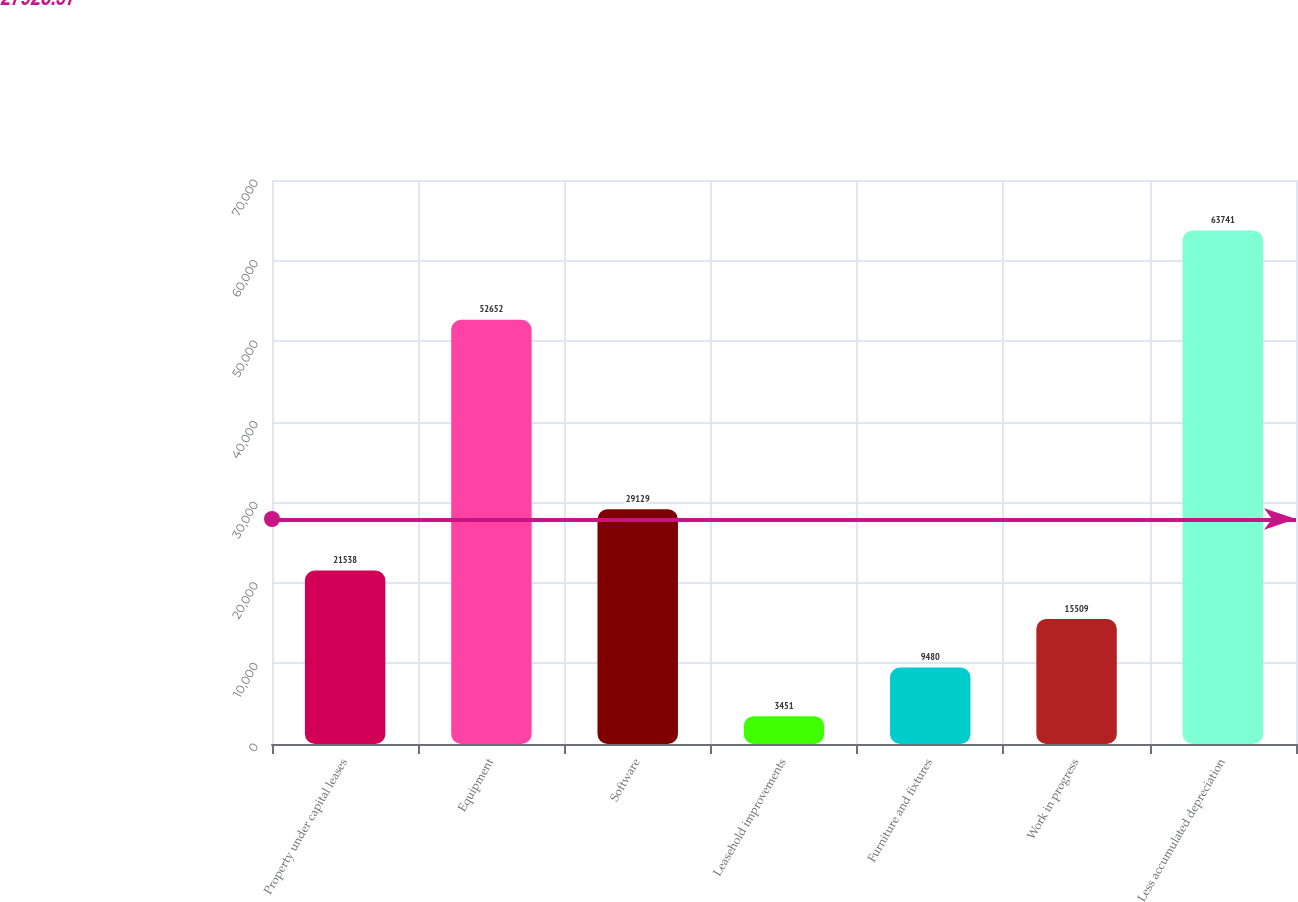<chart> <loc_0><loc_0><loc_500><loc_500><bar_chart><fcel>Property under capital leases<fcel>Equipment<fcel>Software<fcel>Leasehold improvements<fcel>Furniture and fixtures<fcel>Work in progress<fcel>Less accumulated depreciation<nl><fcel>21538<fcel>52652<fcel>29129<fcel>3451<fcel>9480<fcel>15509<fcel>63741<nl></chart> 